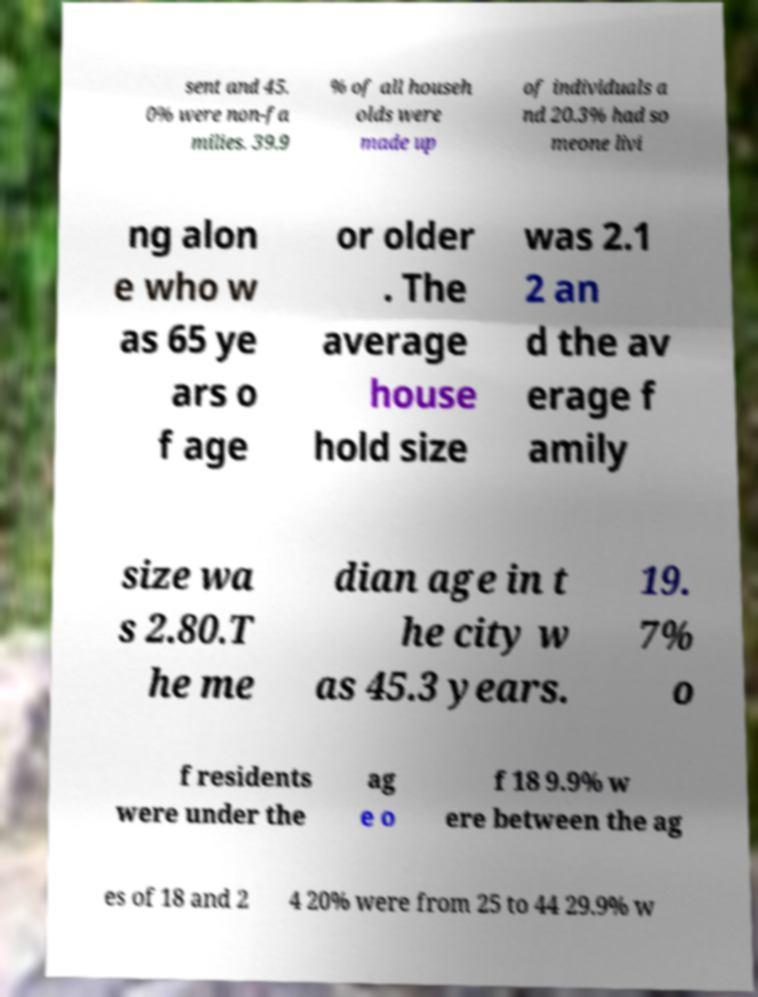What messages or text are displayed in this image? I need them in a readable, typed format. sent and 45. 0% were non-fa milies. 39.9 % of all househ olds were made up of individuals a nd 20.3% had so meone livi ng alon e who w as 65 ye ars o f age or older . The average house hold size was 2.1 2 an d the av erage f amily size wa s 2.80.T he me dian age in t he city w as 45.3 years. 19. 7% o f residents were under the ag e o f 18 9.9% w ere between the ag es of 18 and 2 4 20% were from 25 to 44 29.9% w 